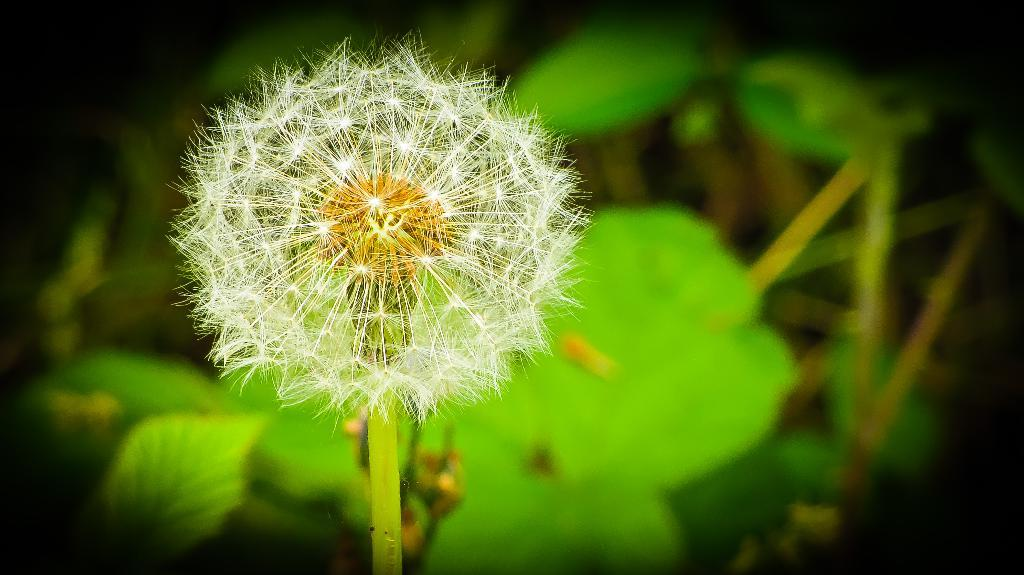What is the main subject of the image? There is a flower in the image. What can be seen in the background of the image? There are leaves visible in the background of the image. What year is depicted in the image? There is no year or any indication of time present in the image. How many pigs are visible in the image? There are no pigs present in the image; it features a flower and leaves. Is there a cart visible in the image? There is no cart present in the image. 